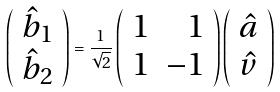<formula> <loc_0><loc_0><loc_500><loc_500>\left ( \begin{array} { c } \hat { b } _ { 1 } \\ \hat { b } _ { 2 } \end{array} \right ) = \frac { 1 } { \sqrt { 2 } } \left ( \begin{array} { r r } 1 & 1 \\ 1 & - 1 \end{array} \right ) \left ( \begin{array} { c } \hat { a } \\ \hat { v } \end{array} \right )</formula> 